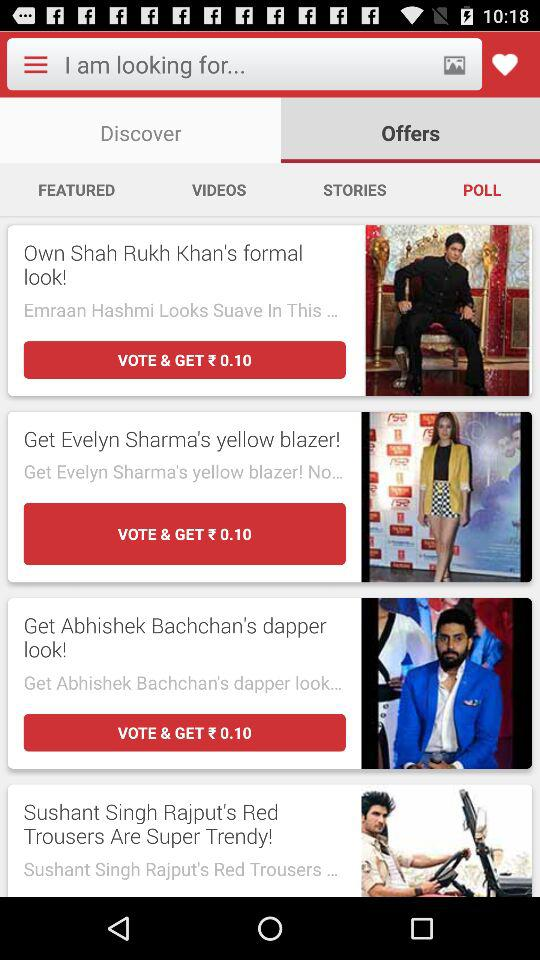How many of the items have a man wearing a suit?
Answer the question using a single word or phrase. 2 